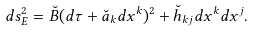Convert formula to latex. <formula><loc_0><loc_0><loc_500><loc_500>d s _ { E } ^ { 2 } = \breve { B } ( d \tau + \breve { a } _ { k } d x ^ { k } ) ^ { 2 } + \breve { h } _ { k j } d x ^ { k } d x ^ { j } .</formula> 